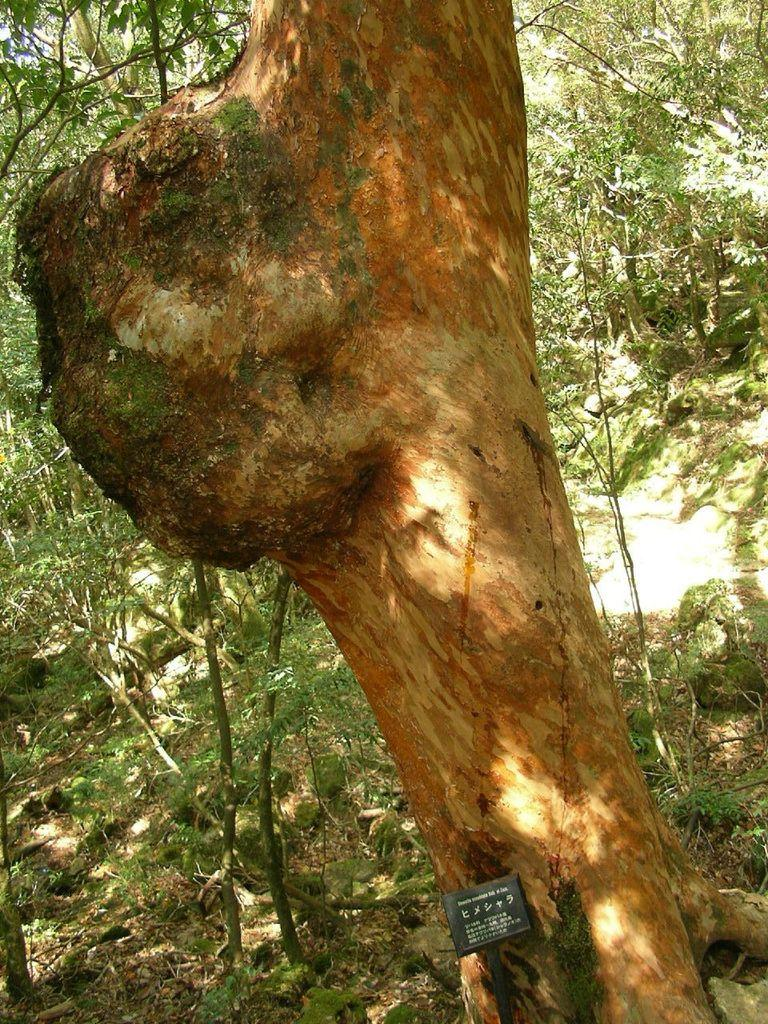What is the main object in the foreground of the image? There is a tree trunk in the image. Is there anything attached to the tree trunk? Yes, a small board is fixed on the tree trunk. What can be seen in the background of the image? There are more trees visible in the background of the image. How many lizards are sitting on the small board in the image? There are no lizards present in the image; it only features a tree trunk with a small board attached. What type of breakfast is being served on the small board in the image? There is no breakfast or any food item present on the small board in the image. 